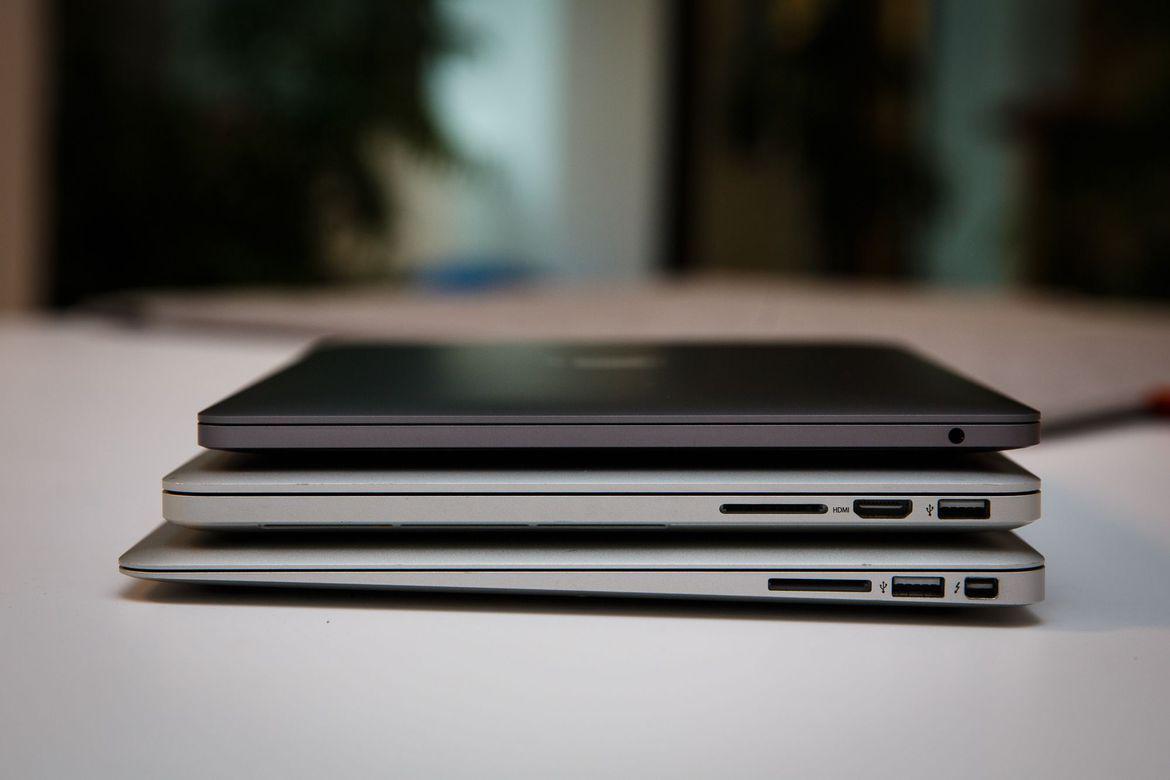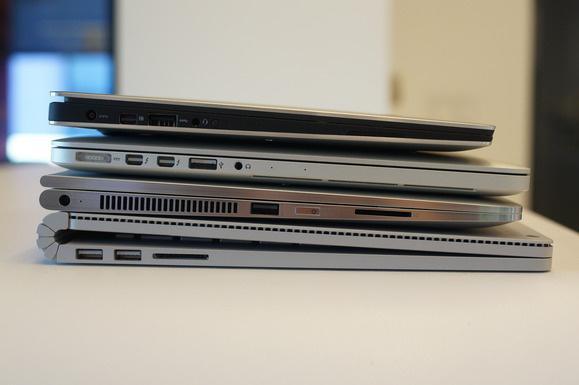The first image is the image on the left, the second image is the image on the right. For the images displayed, is the sentence "In the image on the right 2 laptops are placed side by side." factually correct? Answer yes or no. No. The first image is the image on the left, the second image is the image on the right. Given the left and right images, does the statement "The left image features one closed laptop stacked on another, and the right image shows side-by-side open laptops." hold true? Answer yes or no. No. 